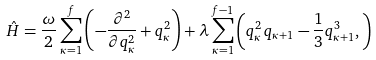Convert formula to latex. <formula><loc_0><loc_0><loc_500><loc_500>\hat { H } = \frac { \omega } { 2 } \sum _ { \kappa = 1 } ^ { f } \left ( - \frac { \partial ^ { 2 } } { \partial q _ { \kappa } ^ { 2 } } + q _ { \kappa } ^ { 2 } \right ) + \lambda \sum _ { \kappa = 1 } ^ { f - 1 } \left ( q _ { \kappa } ^ { 2 } \, q _ { \kappa + 1 } - \frac { 1 } { 3 } q _ { \kappa + 1 } ^ { 3 } , \right )</formula> 